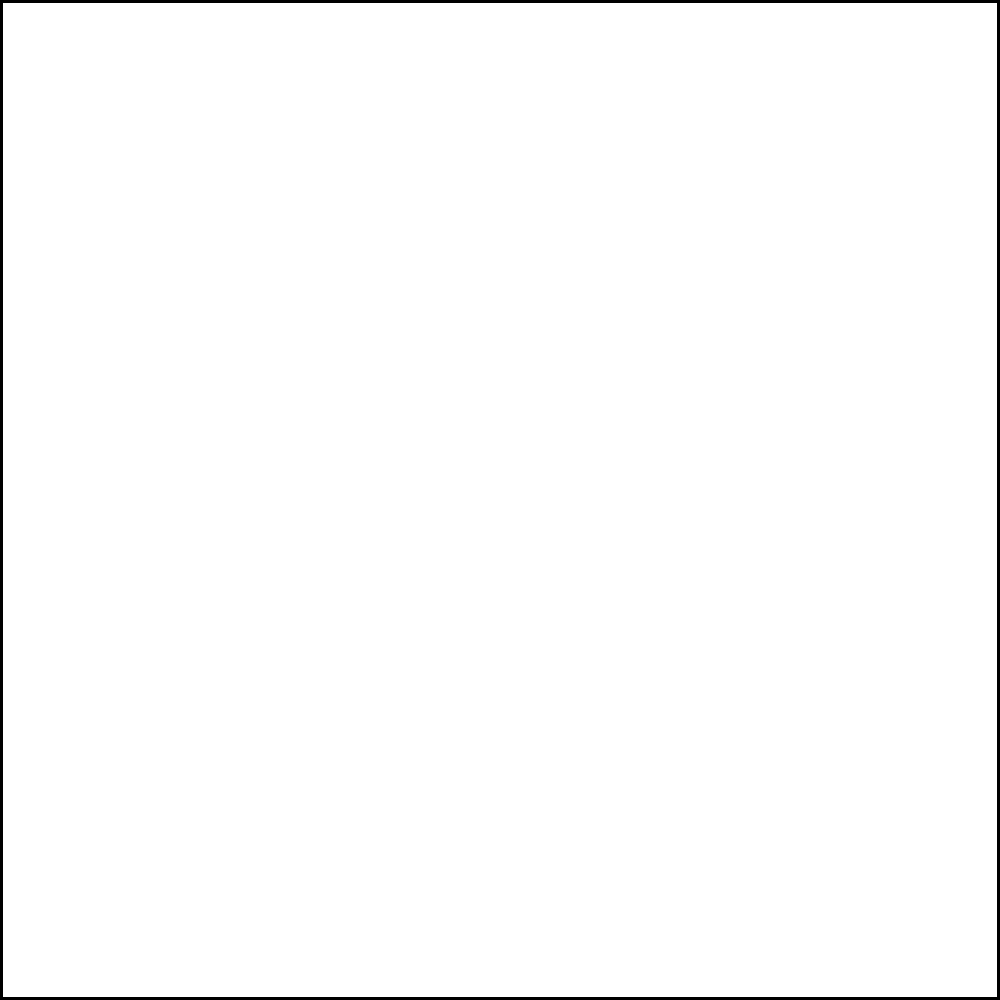Based on the pitch location heat map shown, which area of the strike zone appears to be the batter's biggest weakness, and what type of pitch would you recommend throwing to exploit this weakness? To answer this question, we need to analyze the heat map and interpret its meaning:

1. The heat map shows the effectiveness of pitches in different areas of the strike zone.
2. Darker red areas indicate higher effectiveness (more successful pitches for the pitcher).
3. Lighter red or white areas indicate lower effectiveness (more successful for the batter).

Analyzing the heat map:
1. The darkest red area is in the lower inside corner of the strike zone.
2. This indicates that the batter struggles most with pitches in this location.

To exploit this weakness:
1. Pitches that naturally move to the lower inside corner would be most effective.
2. Breaking balls like curveballs or sliders that start in the strike zone and break down and in would be ideal.
3. For right-handed pitchers facing right-handed batters (or left-handed pitchers facing left-handed batters), a slider would be particularly effective.
4. For opposite-hand matchups, a curveball or two-seam fastball with good movement could work well.

Therefore, the recommendation would be to throw breaking pitches, particularly those that end up in the lower inside corner of the strike zone.
Answer: Lower inside corner; breaking pitches (slider or curveball) 